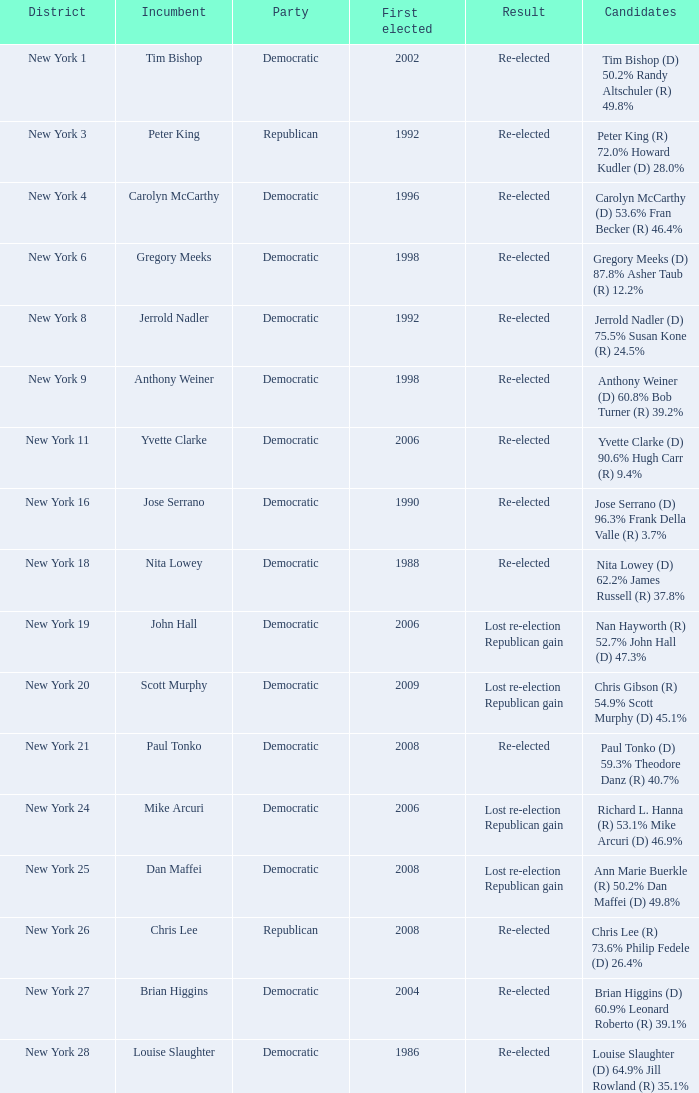Can you parse all the data within this table? {'header': ['District', 'Incumbent', 'Party', 'First elected', 'Result', 'Candidates'], 'rows': [['New York 1', 'Tim Bishop', 'Democratic', '2002', 'Re-elected', 'Tim Bishop (D) 50.2% Randy Altschuler (R) 49.8%'], ['New York 3', 'Peter King', 'Republican', '1992', 'Re-elected', 'Peter King (R) 72.0% Howard Kudler (D) 28.0%'], ['New York 4', 'Carolyn McCarthy', 'Democratic', '1996', 'Re-elected', 'Carolyn McCarthy (D) 53.6% Fran Becker (R) 46.4%'], ['New York 6', 'Gregory Meeks', 'Democratic', '1998', 'Re-elected', 'Gregory Meeks (D) 87.8% Asher Taub (R) 12.2%'], ['New York 8', 'Jerrold Nadler', 'Democratic', '1992', 'Re-elected', 'Jerrold Nadler (D) 75.5% Susan Kone (R) 24.5%'], ['New York 9', 'Anthony Weiner', 'Democratic', '1998', 'Re-elected', 'Anthony Weiner (D) 60.8% Bob Turner (R) 39.2%'], ['New York 11', 'Yvette Clarke', 'Democratic', '2006', 'Re-elected', 'Yvette Clarke (D) 90.6% Hugh Carr (R) 9.4%'], ['New York 16', 'Jose Serrano', 'Democratic', '1990', 'Re-elected', 'Jose Serrano (D) 96.3% Frank Della Valle (R) 3.7%'], ['New York 18', 'Nita Lowey', 'Democratic', '1988', 'Re-elected', 'Nita Lowey (D) 62.2% James Russell (R) 37.8%'], ['New York 19', 'John Hall', 'Democratic', '2006', 'Lost re-election Republican gain', 'Nan Hayworth (R) 52.7% John Hall (D) 47.3%'], ['New York 20', 'Scott Murphy', 'Democratic', '2009', 'Lost re-election Republican gain', 'Chris Gibson (R) 54.9% Scott Murphy (D) 45.1%'], ['New York 21', 'Paul Tonko', 'Democratic', '2008', 'Re-elected', 'Paul Tonko (D) 59.3% Theodore Danz (R) 40.7%'], ['New York 24', 'Mike Arcuri', 'Democratic', '2006', 'Lost re-election Republican gain', 'Richard L. Hanna (R) 53.1% Mike Arcuri (D) 46.9%'], ['New York 25', 'Dan Maffei', 'Democratic', '2008', 'Lost re-election Republican gain', 'Ann Marie Buerkle (R) 50.2% Dan Maffei (D) 49.8%'], ['New York 26', 'Chris Lee', 'Republican', '2008', 'Re-elected', 'Chris Lee (R) 73.6% Philip Fedele (D) 26.4%'], ['New York 27', 'Brian Higgins', 'Democratic', '2004', 'Re-elected', 'Brian Higgins (D) 60.9% Leonard Roberto (R) 39.1%'], ['New York 28', 'Louise Slaughter', 'Democratic', '1986', 'Re-elected', 'Louise Slaughter (D) 64.9% Jill Rowland (R) 35.1%']]} Name the party for yvette clarke (d) 90.6% hugh carr (r) 9.4% Democratic. 